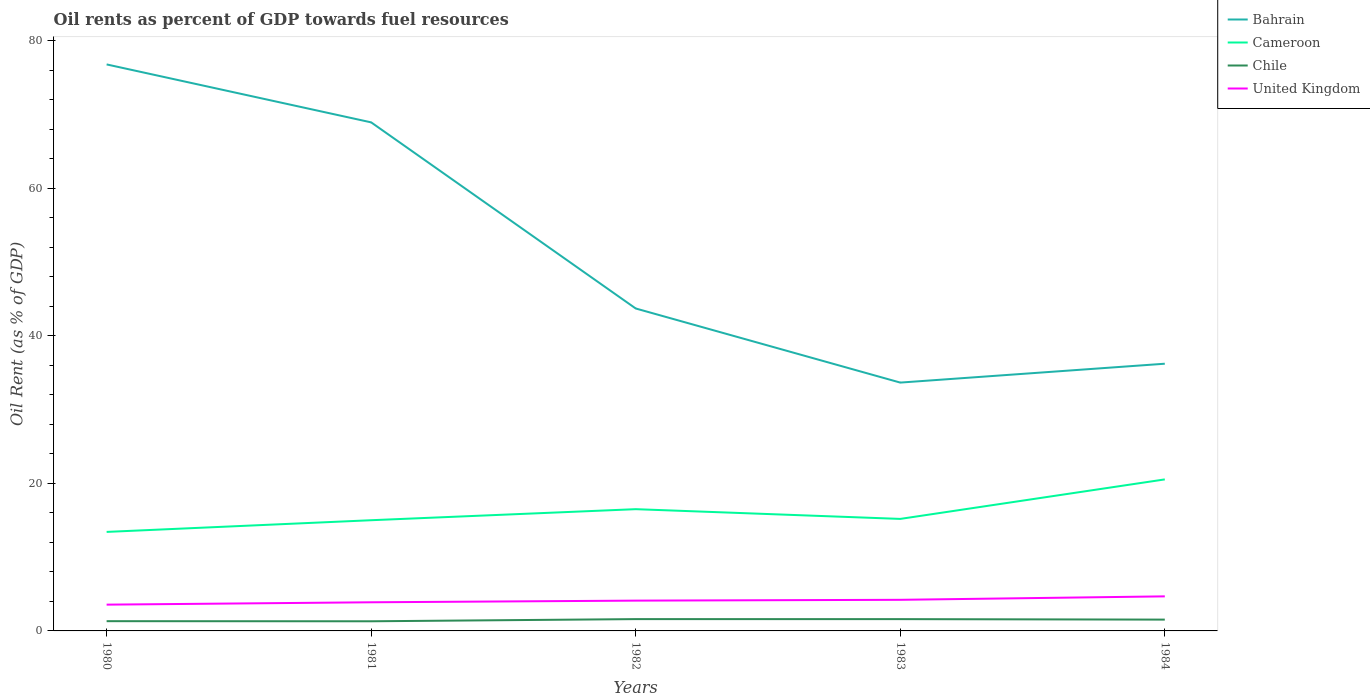Does the line corresponding to Bahrain intersect with the line corresponding to United Kingdom?
Ensure brevity in your answer.  No. Across all years, what is the maximum oil rent in Cameroon?
Make the answer very short. 13.42. In which year was the oil rent in Chile maximum?
Keep it short and to the point. 1981. What is the total oil rent in Cameroon in the graph?
Ensure brevity in your answer.  -3.08. What is the difference between the highest and the second highest oil rent in Cameroon?
Ensure brevity in your answer.  7.12. What is the difference between the highest and the lowest oil rent in United Kingdom?
Keep it short and to the point. 3. How many years are there in the graph?
Provide a short and direct response. 5. What is the difference between two consecutive major ticks on the Y-axis?
Ensure brevity in your answer.  20. Are the values on the major ticks of Y-axis written in scientific E-notation?
Your answer should be compact. No. Does the graph contain any zero values?
Make the answer very short. No. Does the graph contain grids?
Make the answer very short. No. What is the title of the graph?
Offer a terse response. Oil rents as percent of GDP towards fuel resources. What is the label or title of the X-axis?
Provide a short and direct response. Years. What is the label or title of the Y-axis?
Your answer should be compact. Oil Rent (as % of GDP). What is the Oil Rent (as % of GDP) in Bahrain in 1980?
Ensure brevity in your answer.  76.81. What is the Oil Rent (as % of GDP) in Cameroon in 1980?
Ensure brevity in your answer.  13.42. What is the Oil Rent (as % of GDP) in Chile in 1980?
Make the answer very short. 1.32. What is the Oil Rent (as % of GDP) of United Kingdom in 1980?
Provide a short and direct response. 3.56. What is the Oil Rent (as % of GDP) of Bahrain in 1981?
Your answer should be compact. 68.95. What is the Oil Rent (as % of GDP) of Cameroon in 1981?
Give a very brief answer. 15.01. What is the Oil Rent (as % of GDP) of Chile in 1981?
Give a very brief answer. 1.31. What is the Oil Rent (as % of GDP) of United Kingdom in 1981?
Ensure brevity in your answer.  3.88. What is the Oil Rent (as % of GDP) in Bahrain in 1982?
Offer a very short reply. 43.72. What is the Oil Rent (as % of GDP) of Cameroon in 1982?
Your answer should be very brief. 16.51. What is the Oil Rent (as % of GDP) in Chile in 1982?
Offer a terse response. 1.6. What is the Oil Rent (as % of GDP) in United Kingdom in 1982?
Your response must be concise. 4.11. What is the Oil Rent (as % of GDP) in Bahrain in 1983?
Provide a short and direct response. 33.67. What is the Oil Rent (as % of GDP) in Cameroon in 1983?
Provide a short and direct response. 15.19. What is the Oil Rent (as % of GDP) in Chile in 1983?
Ensure brevity in your answer.  1.6. What is the Oil Rent (as % of GDP) in United Kingdom in 1983?
Give a very brief answer. 4.22. What is the Oil Rent (as % of GDP) of Bahrain in 1984?
Your response must be concise. 36.23. What is the Oil Rent (as % of GDP) of Cameroon in 1984?
Provide a short and direct response. 20.54. What is the Oil Rent (as % of GDP) in Chile in 1984?
Give a very brief answer. 1.53. What is the Oil Rent (as % of GDP) in United Kingdom in 1984?
Offer a very short reply. 4.69. Across all years, what is the maximum Oil Rent (as % of GDP) of Bahrain?
Offer a very short reply. 76.81. Across all years, what is the maximum Oil Rent (as % of GDP) in Cameroon?
Ensure brevity in your answer.  20.54. Across all years, what is the maximum Oil Rent (as % of GDP) of Chile?
Offer a very short reply. 1.6. Across all years, what is the maximum Oil Rent (as % of GDP) in United Kingdom?
Give a very brief answer. 4.69. Across all years, what is the minimum Oil Rent (as % of GDP) of Bahrain?
Provide a succinct answer. 33.67. Across all years, what is the minimum Oil Rent (as % of GDP) in Cameroon?
Keep it short and to the point. 13.42. Across all years, what is the minimum Oil Rent (as % of GDP) in Chile?
Offer a terse response. 1.31. Across all years, what is the minimum Oil Rent (as % of GDP) in United Kingdom?
Your response must be concise. 3.56. What is the total Oil Rent (as % of GDP) of Bahrain in the graph?
Provide a succinct answer. 259.38. What is the total Oil Rent (as % of GDP) in Cameroon in the graph?
Your answer should be very brief. 80.67. What is the total Oil Rent (as % of GDP) of Chile in the graph?
Make the answer very short. 7.36. What is the total Oil Rent (as % of GDP) of United Kingdom in the graph?
Your answer should be compact. 20.46. What is the difference between the Oil Rent (as % of GDP) in Bahrain in 1980 and that in 1981?
Your answer should be very brief. 7.86. What is the difference between the Oil Rent (as % of GDP) of Cameroon in 1980 and that in 1981?
Make the answer very short. -1.58. What is the difference between the Oil Rent (as % of GDP) in Chile in 1980 and that in 1981?
Your response must be concise. 0.02. What is the difference between the Oil Rent (as % of GDP) of United Kingdom in 1980 and that in 1981?
Provide a short and direct response. -0.32. What is the difference between the Oil Rent (as % of GDP) in Bahrain in 1980 and that in 1982?
Your answer should be very brief. 33.09. What is the difference between the Oil Rent (as % of GDP) of Cameroon in 1980 and that in 1982?
Your answer should be very brief. -3.08. What is the difference between the Oil Rent (as % of GDP) in Chile in 1980 and that in 1982?
Offer a very short reply. -0.28. What is the difference between the Oil Rent (as % of GDP) in United Kingdom in 1980 and that in 1982?
Give a very brief answer. -0.55. What is the difference between the Oil Rent (as % of GDP) of Bahrain in 1980 and that in 1983?
Your answer should be compact. 43.14. What is the difference between the Oil Rent (as % of GDP) in Cameroon in 1980 and that in 1983?
Your answer should be very brief. -1.76. What is the difference between the Oil Rent (as % of GDP) of Chile in 1980 and that in 1983?
Offer a very short reply. -0.28. What is the difference between the Oil Rent (as % of GDP) in United Kingdom in 1980 and that in 1983?
Make the answer very short. -0.66. What is the difference between the Oil Rent (as % of GDP) in Bahrain in 1980 and that in 1984?
Your answer should be very brief. 40.58. What is the difference between the Oil Rent (as % of GDP) in Cameroon in 1980 and that in 1984?
Offer a very short reply. -7.12. What is the difference between the Oil Rent (as % of GDP) of Chile in 1980 and that in 1984?
Your answer should be very brief. -0.21. What is the difference between the Oil Rent (as % of GDP) in United Kingdom in 1980 and that in 1984?
Provide a short and direct response. -1.12. What is the difference between the Oil Rent (as % of GDP) in Bahrain in 1981 and that in 1982?
Ensure brevity in your answer.  25.23. What is the difference between the Oil Rent (as % of GDP) of Cameroon in 1981 and that in 1982?
Your answer should be very brief. -1.5. What is the difference between the Oil Rent (as % of GDP) in Chile in 1981 and that in 1982?
Provide a succinct answer. -0.29. What is the difference between the Oil Rent (as % of GDP) in United Kingdom in 1981 and that in 1982?
Keep it short and to the point. -0.23. What is the difference between the Oil Rent (as % of GDP) of Bahrain in 1981 and that in 1983?
Provide a succinct answer. 35.28. What is the difference between the Oil Rent (as % of GDP) of Cameroon in 1981 and that in 1983?
Keep it short and to the point. -0.18. What is the difference between the Oil Rent (as % of GDP) of Chile in 1981 and that in 1983?
Give a very brief answer. -0.29. What is the difference between the Oil Rent (as % of GDP) of United Kingdom in 1981 and that in 1983?
Provide a short and direct response. -0.34. What is the difference between the Oil Rent (as % of GDP) of Bahrain in 1981 and that in 1984?
Offer a very short reply. 32.72. What is the difference between the Oil Rent (as % of GDP) in Cameroon in 1981 and that in 1984?
Offer a terse response. -5.54. What is the difference between the Oil Rent (as % of GDP) of Chile in 1981 and that in 1984?
Provide a succinct answer. -0.23. What is the difference between the Oil Rent (as % of GDP) of United Kingdom in 1981 and that in 1984?
Your response must be concise. -0.8. What is the difference between the Oil Rent (as % of GDP) of Bahrain in 1982 and that in 1983?
Ensure brevity in your answer.  10.05. What is the difference between the Oil Rent (as % of GDP) in Cameroon in 1982 and that in 1983?
Offer a very short reply. 1.32. What is the difference between the Oil Rent (as % of GDP) in Chile in 1982 and that in 1983?
Your answer should be compact. 0. What is the difference between the Oil Rent (as % of GDP) of United Kingdom in 1982 and that in 1983?
Give a very brief answer. -0.11. What is the difference between the Oil Rent (as % of GDP) in Bahrain in 1982 and that in 1984?
Make the answer very short. 7.49. What is the difference between the Oil Rent (as % of GDP) of Cameroon in 1982 and that in 1984?
Your answer should be very brief. -4.04. What is the difference between the Oil Rent (as % of GDP) of Chile in 1982 and that in 1984?
Keep it short and to the point. 0.07. What is the difference between the Oil Rent (as % of GDP) in United Kingdom in 1982 and that in 1984?
Keep it short and to the point. -0.58. What is the difference between the Oil Rent (as % of GDP) in Bahrain in 1983 and that in 1984?
Your answer should be compact. -2.56. What is the difference between the Oil Rent (as % of GDP) in Cameroon in 1983 and that in 1984?
Provide a succinct answer. -5.36. What is the difference between the Oil Rent (as % of GDP) of Chile in 1983 and that in 1984?
Your answer should be compact. 0.07. What is the difference between the Oil Rent (as % of GDP) in United Kingdom in 1983 and that in 1984?
Keep it short and to the point. -0.47. What is the difference between the Oil Rent (as % of GDP) in Bahrain in 1980 and the Oil Rent (as % of GDP) in Cameroon in 1981?
Give a very brief answer. 61.8. What is the difference between the Oil Rent (as % of GDP) of Bahrain in 1980 and the Oil Rent (as % of GDP) of Chile in 1981?
Provide a short and direct response. 75.5. What is the difference between the Oil Rent (as % of GDP) of Bahrain in 1980 and the Oil Rent (as % of GDP) of United Kingdom in 1981?
Provide a succinct answer. 72.93. What is the difference between the Oil Rent (as % of GDP) in Cameroon in 1980 and the Oil Rent (as % of GDP) in Chile in 1981?
Provide a short and direct response. 12.12. What is the difference between the Oil Rent (as % of GDP) of Cameroon in 1980 and the Oil Rent (as % of GDP) of United Kingdom in 1981?
Your answer should be very brief. 9.54. What is the difference between the Oil Rent (as % of GDP) in Chile in 1980 and the Oil Rent (as % of GDP) in United Kingdom in 1981?
Your answer should be very brief. -2.56. What is the difference between the Oil Rent (as % of GDP) in Bahrain in 1980 and the Oil Rent (as % of GDP) in Cameroon in 1982?
Provide a short and direct response. 60.3. What is the difference between the Oil Rent (as % of GDP) in Bahrain in 1980 and the Oil Rent (as % of GDP) in Chile in 1982?
Your answer should be very brief. 75.21. What is the difference between the Oil Rent (as % of GDP) of Bahrain in 1980 and the Oil Rent (as % of GDP) of United Kingdom in 1982?
Give a very brief answer. 72.7. What is the difference between the Oil Rent (as % of GDP) of Cameroon in 1980 and the Oil Rent (as % of GDP) of Chile in 1982?
Your answer should be compact. 11.82. What is the difference between the Oil Rent (as % of GDP) in Cameroon in 1980 and the Oil Rent (as % of GDP) in United Kingdom in 1982?
Ensure brevity in your answer.  9.32. What is the difference between the Oil Rent (as % of GDP) in Chile in 1980 and the Oil Rent (as % of GDP) in United Kingdom in 1982?
Ensure brevity in your answer.  -2.79. What is the difference between the Oil Rent (as % of GDP) of Bahrain in 1980 and the Oil Rent (as % of GDP) of Cameroon in 1983?
Give a very brief answer. 61.62. What is the difference between the Oil Rent (as % of GDP) in Bahrain in 1980 and the Oil Rent (as % of GDP) in Chile in 1983?
Offer a very short reply. 75.21. What is the difference between the Oil Rent (as % of GDP) in Bahrain in 1980 and the Oil Rent (as % of GDP) in United Kingdom in 1983?
Give a very brief answer. 72.59. What is the difference between the Oil Rent (as % of GDP) in Cameroon in 1980 and the Oil Rent (as % of GDP) in Chile in 1983?
Give a very brief answer. 11.82. What is the difference between the Oil Rent (as % of GDP) of Cameroon in 1980 and the Oil Rent (as % of GDP) of United Kingdom in 1983?
Provide a succinct answer. 9.21. What is the difference between the Oil Rent (as % of GDP) of Chile in 1980 and the Oil Rent (as % of GDP) of United Kingdom in 1983?
Your response must be concise. -2.9. What is the difference between the Oil Rent (as % of GDP) of Bahrain in 1980 and the Oil Rent (as % of GDP) of Cameroon in 1984?
Your response must be concise. 56.27. What is the difference between the Oil Rent (as % of GDP) in Bahrain in 1980 and the Oil Rent (as % of GDP) in Chile in 1984?
Make the answer very short. 75.28. What is the difference between the Oil Rent (as % of GDP) in Bahrain in 1980 and the Oil Rent (as % of GDP) in United Kingdom in 1984?
Your answer should be very brief. 72.12. What is the difference between the Oil Rent (as % of GDP) of Cameroon in 1980 and the Oil Rent (as % of GDP) of Chile in 1984?
Make the answer very short. 11.89. What is the difference between the Oil Rent (as % of GDP) of Cameroon in 1980 and the Oil Rent (as % of GDP) of United Kingdom in 1984?
Make the answer very short. 8.74. What is the difference between the Oil Rent (as % of GDP) of Chile in 1980 and the Oil Rent (as % of GDP) of United Kingdom in 1984?
Provide a succinct answer. -3.36. What is the difference between the Oil Rent (as % of GDP) of Bahrain in 1981 and the Oil Rent (as % of GDP) of Cameroon in 1982?
Provide a short and direct response. 52.45. What is the difference between the Oil Rent (as % of GDP) in Bahrain in 1981 and the Oil Rent (as % of GDP) in Chile in 1982?
Your answer should be very brief. 67.35. What is the difference between the Oil Rent (as % of GDP) in Bahrain in 1981 and the Oil Rent (as % of GDP) in United Kingdom in 1982?
Provide a succinct answer. 64.84. What is the difference between the Oil Rent (as % of GDP) in Cameroon in 1981 and the Oil Rent (as % of GDP) in Chile in 1982?
Keep it short and to the point. 13.41. What is the difference between the Oil Rent (as % of GDP) in Cameroon in 1981 and the Oil Rent (as % of GDP) in United Kingdom in 1982?
Ensure brevity in your answer.  10.9. What is the difference between the Oil Rent (as % of GDP) in Chile in 1981 and the Oil Rent (as % of GDP) in United Kingdom in 1982?
Offer a terse response. -2.8. What is the difference between the Oil Rent (as % of GDP) in Bahrain in 1981 and the Oil Rent (as % of GDP) in Cameroon in 1983?
Make the answer very short. 53.77. What is the difference between the Oil Rent (as % of GDP) of Bahrain in 1981 and the Oil Rent (as % of GDP) of Chile in 1983?
Offer a very short reply. 67.35. What is the difference between the Oil Rent (as % of GDP) in Bahrain in 1981 and the Oil Rent (as % of GDP) in United Kingdom in 1983?
Your response must be concise. 64.73. What is the difference between the Oil Rent (as % of GDP) of Cameroon in 1981 and the Oil Rent (as % of GDP) of Chile in 1983?
Offer a terse response. 13.41. What is the difference between the Oil Rent (as % of GDP) in Cameroon in 1981 and the Oil Rent (as % of GDP) in United Kingdom in 1983?
Ensure brevity in your answer.  10.79. What is the difference between the Oil Rent (as % of GDP) of Chile in 1981 and the Oil Rent (as % of GDP) of United Kingdom in 1983?
Ensure brevity in your answer.  -2.91. What is the difference between the Oil Rent (as % of GDP) in Bahrain in 1981 and the Oil Rent (as % of GDP) in Cameroon in 1984?
Give a very brief answer. 48.41. What is the difference between the Oil Rent (as % of GDP) of Bahrain in 1981 and the Oil Rent (as % of GDP) of Chile in 1984?
Give a very brief answer. 67.42. What is the difference between the Oil Rent (as % of GDP) of Bahrain in 1981 and the Oil Rent (as % of GDP) of United Kingdom in 1984?
Offer a very short reply. 64.27. What is the difference between the Oil Rent (as % of GDP) in Cameroon in 1981 and the Oil Rent (as % of GDP) in Chile in 1984?
Ensure brevity in your answer.  13.47. What is the difference between the Oil Rent (as % of GDP) in Cameroon in 1981 and the Oil Rent (as % of GDP) in United Kingdom in 1984?
Your answer should be compact. 10.32. What is the difference between the Oil Rent (as % of GDP) of Chile in 1981 and the Oil Rent (as % of GDP) of United Kingdom in 1984?
Offer a very short reply. -3.38. What is the difference between the Oil Rent (as % of GDP) in Bahrain in 1982 and the Oil Rent (as % of GDP) in Cameroon in 1983?
Your answer should be compact. 28.53. What is the difference between the Oil Rent (as % of GDP) in Bahrain in 1982 and the Oil Rent (as % of GDP) in Chile in 1983?
Offer a terse response. 42.12. What is the difference between the Oil Rent (as % of GDP) of Bahrain in 1982 and the Oil Rent (as % of GDP) of United Kingdom in 1983?
Provide a short and direct response. 39.5. What is the difference between the Oil Rent (as % of GDP) in Cameroon in 1982 and the Oil Rent (as % of GDP) in Chile in 1983?
Keep it short and to the point. 14.91. What is the difference between the Oil Rent (as % of GDP) in Cameroon in 1982 and the Oil Rent (as % of GDP) in United Kingdom in 1983?
Your answer should be compact. 12.29. What is the difference between the Oil Rent (as % of GDP) in Chile in 1982 and the Oil Rent (as % of GDP) in United Kingdom in 1983?
Your answer should be compact. -2.62. What is the difference between the Oil Rent (as % of GDP) of Bahrain in 1982 and the Oil Rent (as % of GDP) of Cameroon in 1984?
Offer a terse response. 23.17. What is the difference between the Oil Rent (as % of GDP) in Bahrain in 1982 and the Oil Rent (as % of GDP) in Chile in 1984?
Ensure brevity in your answer.  42.18. What is the difference between the Oil Rent (as % of GDP) in Bahrain in 1982 and the Oil Rent (as % of GDP) in United Kingdom in 1984?
Provide a succinct answer. 39.03. What is the difference between the Oil Rent (as % of GDP) of Cameroon in 1982 and the Oil Rent (as % of GDP) of Chile in 1984?
Give a very brief answer. 14.97. What is the difference between the Oil Rent (as % of GDP) in Cameroon in 1982 and the Oil Rent (as % of GDP) in United Kingdom in 1984?
Your response must be concise. 11.82. What is the difference between the Oil Rent (as % of GDP) in Chile in 1982 and the Oil Rent (as % of GDP) in United Kingdom in 1984?
Provide a short and direct response. -3.09. What is the difference between the Oil Rent (as % of GDP) in Bahrain in 1983 and the Oil Rent (as % of GDP) in Cameroon in 1984?
Your answer should be compact. 13.13. What is the difference between the Oil Rent (as % of GDP) of Bahrain in 1983 and the Oil Rent (as % of GDP) of Chile in 1984?
Provide a succinct answer. 32.14. What is the difference between the Oil Rent (as % of GDP) of Bahrain in 1983 and the Oil Rent (as % of GDP) of United Kingdom in 1984?
Provide a succinct answer. 28.98. What is the difference between the Oil Rent (as % of GDP) of Cameroon in 1983 and the Oil Rent (as % of GDP) of Chile in 1984?
Keep it short and to the point. 13.65. What is the difference between the Oil Rent (as % of GDP) in Cameroon in 1983 and the Oil Rent (as % of GDP) in United Kingdom in 1984?
Your response must be concise. 10.5. What is the difference between the Oil Rent (as % of GDP) in Chile in 1983 and the Oil Rent (as % of GDP) in United Kingdom in 1984?
Give a very brief answer. -3.09. What is the average Oil Rent (as % of GDP) in Bahrain per year?
Offer a very short reply. 51.88. What is the average Oil Rent (as % of GDP) in Cameroon per year?
Offer a very short reply. 16.13. What is the average Oil Rent (as % of GDP) of Chile per year?
Give a very brief answer. 1.47. What is the average Oil Rent (as % of GDP) in United Kingdom per year?
Your answer should be very brief. 4.09. In the year 1980, what is the difference between the Oil Rent (as % of GDP) in Bahrain and Oil Rent (as % of GDP) in Cameroon?
Provide a short and direct response. 63.39. In the year 1980, what is the difference between the Oil Rent (as % of GDP) in Bahrain and Oil Rent (as % of GDP) in Chile?
Your answer should be compact. 75.49. In the year 1980, what is the difference between the Oil Rent (as % of GDP) in Bahrain and Oil Rent (as % of GDP) in United Kingdom?
Make the answer very short. 73.25. In the year 1980, what is the difference between the Oil Rent (as % of GDP) in Cameroon and Oil Rent (as % of GDP) in Chile?
Your response must be concise. 12.1. In the year 1980, what is the difference between the Oil Rent (as % of GDP) in Cameroon and Oil Rent (as % of GDP) in United Kingdom?
Ensure brevity in your answer.  9.86. In the year 1980, what is the difference between the Oil Rent (as % of GDP) of Chile and Oil Rent (as % of GDP) of United Kingdom?
Give a very brief answer. -2.24. In the year 1981, what is the difference between the Oil Rent (as % of GDP) of Bahrain and Oil Rent (as % of GDP) of Cameroon?
Your answer should be very brief. 53.94. In the year 1981, what is the difference between the Oil Rent (as % of GDP) of Bahrain and Oil Rent (as % of GDP) of Chile?
Your response must be concise. 67.65. In the year 1981, what is the difference between the Oil Rent (as % of GDP) of Bahrain and Oil Rent (as % of GDP) of United Kingdom?
Keep it short and to the point. 65.07. In the year 1981, what is the difference between the Oil Rent (as % of GDP) of Cameroon and Oil Rent (as % of GDP) of Chile?
Offer a very short reply. 13.7. In the year 1981, what is the difference between the Oil Rent (as % of GDP) in Cameroon and Oil Rent (as % of GDP) in United Kingdom?
Provide a succinct answer. 11.13. In the year 1981, what is the difference between the Oil Rent (as % of GDP) in Chile and Oil Rent (as % of GDP) in United Kingdom?
Offer a very short reply. -2.58. In the year 1982, what is the difference between the Oil Rent (as % of GDP) of Bahrain and Oil Rent (as % of GDP) of Cameroon?
Make the answer very short. 27.21. In the year 1982, what is the difference between the Oil Rent (as % of GDP) of Bahrain and Oil Rent (as % of GDP) of Chile?
Your answer should be compact. 42.12. In the year 1982, what is the difference between the Oil Rent (as % of GDP) of Bahrain and Oil Rent (as % of GDP) of United Kingdom?
Offer a terse response. 39.61. In the year 1982, what is the difference between the Oil Rent (as % of GDP) in Cameroon and Oil Rent (as % of GDP) in Chile?
Your answer should be very brief. 14.91. In the year 1982, what is the difference between the Oil Rent (as % of GDP) in Cameroon and Oil Rent (as % of GDP) in United Kingdom?
Provide a short and direct response. 12.4. In the year 1982, what is the difference between the Oil Rent (as % of GDP) of Chile and Oil Rent (as % of GDP) of United Kingdom?
Your response must be concise. -2.51. In the year 1983, what is the difference between the Oil Rent (as % of GDP) in Bahrain and Oil Rent (as % of GDP) in Cameroon?
Give a very brief answer. 18.48. In the year 1983, what is the difference between the Oil Rent (as % of GDP) in Bahrain and Oil Rent (as % of GDP) in Chile?
Provide a succinct answer. 32.07. In the year 1983, what is the difference between the Oil Rent (as % of GDP) of Bahrain and Oil Rent (as % of GDP) of United Kingdom?
Give a very brief answer. 29.45. In the year 1983, what is the difference between the Oil Rent (as % of GDP) of Cameroon and Oil Rent (as % of GDP) of Chile?
Ensure brevity in your answer.  13.59. In the year 1983, what is the difference between the Oil Rent (as % of GDP) of Cameroon and Oil Rent (as % of GDP) of United Kingdom?
Ensure brevity in your answer.  10.97. In the year 1983, what is the difference between the Oil Rent (as % of GDP) in Chile and Oil Rent (as % of GDP) in United Kingdom?
Make the answer very short. -2.62. In the year 1984, what is the difference between the Oil Rent (as % of GDP) in Bahrain and Oil Rent (as % of GDP) in Cameroon?
Offer a very short reply. 15.68. In the year 1984, what is the difference between the Oil Rent (as % of GDP) in Bahrain and Oil Rent (as % of GDP) in Chile?
Keep it short and to the point. 34.69. In the year 1984, what is the difference between the Oil Rent (as % of GDP) of Bahrain and Oil Rent (as % of GDP) of United Kingdom?
Give a very brief answer. 31.54. In the year 1984, what is the difference between the Oil Rent (as % of GDP) in Cameroon and Oil Rent (as % of GDP) in Chile?
Give a very brief answer. 19.01. In the year 1984, what is the difference between the Oil Rent (as % of GDP) of Cameroon and Oil Rent (as % of GDP) of United Kingdom?
Make the answer very short. 15.86. In the year 1984, what is the difference between the Oil Rent (as % of GDP) of Chile and Oil Rent (as % of GDP) of United Kingdom?
Your answer should be very brief. -3.15. What is the ratio of the Oil Rent (as % of GDP) of Bahrain in 1980 to that in 1981?
Ensure brevity in your answer.  1.11. What is the ratio of the Oil Rent (as % of GDP) of Cameroon in 1980 to that in 1981?
Offer a very short reply. 0.89. What is the ratio of the Oil Rent (as % of GDP) in Chile in 1980 to that in 1981?
Keep it short and to the point. 1.01. What is the ratio of the Oil Rent (as % of GDP) of United Kingdom in 1980 to that in 1981?
Offer a very short reply. 0.92. What is the ratio of the Oil Rent (as % of GDP) in Bahrain in 1980 to that in 1982?
Ensure brevity in your answer.  1.76. What is the ratio of the Oil Rent (as % of GDP) of Cameroon in 1980 to that in 1982?
Make the answer very short. 0.81. What is the ratio of the Oil Rent (as % of GDP) in Chile in 1980 to that in 1982?
Your response must be concise. 0.83. What is the ratio of the Oil Rent (as % of GDP) of United Kingdom in 1980 to that in 1982?
Provide a short and direct response. 0.87. What is the ratio of the Oil Rent (as % of GDP) of Bahrain in 1980 to that in 1983?
Keep it short and to the point. 2.28. What is the ratio of the Oil Rent (as % of GDP) of Cameroon in 1980 to that in 1983?
Your answer should be compact. 0.88. What is the ratio of the Oil Rent (as % of GDP) of Chile in 1980 to that in 1983?
Ensure brevity in your answer.  0.83. What is the ratio of the Oil Rent (as % of GDP) of United Kingdom in 1980 to that in 1983?
Offer a terse response. 0.84. What is the ratio of the Oil Rent (as % of GDP) of Bahrain in 1980 to that in 1984?
Provide a succinct answer. 2.12. What is the ratio of the Oil Rent (as % of GDP) of Cameroon in 1980 to that in 1984?
Offer a very short reply. 0.65. What is the ratio of the Oil Rent (as % of GDP) of Chile in 1980 to that in 1984?
Offer a terse response. 0.86. What is the ratio of the Oil Rent (as % of GDP) of United Kingdom in 1980 to that in 1984?
Provide a succinct answer. 0.76. What is the ratio of the Oil Rent (as % of GDP) of Bahrain in 1981 to that in 1982?
Offer a terse response. 1.58. What is the ratio of the Oil Rent (as % of GDP) in Cameroon in 1981 to that in 1982?
Provide a succinct answer. 0.91. What is the ratio of the Oil Rent (as % of GDP) of Chile in 1981 to that in 1982?
Offer a terse response. 0.82. What is the ratio of the Oil Rent (as % of GDP) in United Kingdom in 1981 to that in 1982?
Your answer should be compact. 0.95. What is the ratio of the Oil Rent (as % of GDP) of Bahrain in 1981 to that in 1983?
Ensure brevity in your answer.  2.05. What is the ratio of the Oil Rent (as % of GDP) of Cameroon in 1981 to that in 1983?
Make the answer very short. 0.99. What is the ratio of the Oil Rent (as % of GDP) in Chile in 1981 to that in 1983?
Your answer should be very brief. 0.82. What is the ratio of the Oil Rent (as % of GDP) of United Kingdom in 1981 to that in 1983?
Keep it short and to the point. 0.92. What is the ratio of the Oil Rent (as % of GDP) in Bahrain in 1981 to that in 1984?
Give a very brief answer. 1.9. What is the ratio of the Oil Rent (as % of GDP) in Cameroon in 1981 to that in 1984?
Your answer should be very brief. 0.73. What is the ratio of the Oil Rent (as % of GDP) of Chile in 1981 to that in 1984?
Your answer should be compact. 0.85. What is the ratio of the Oil Rent (as % of GDP) in United Kingdom in 1981 to that in 1984?
Your response must be concise. 0.83. What is the ratio of the Oil Rent (as % of GDP) of Bahrain in 1982 to that in 1983?
Give a very brief answer. 1.3. What is the ratio of the Oil Rent (as % of GDP) in Cameroon in 1982 to that in 1983?
Keep it short and to the point. 1.09. What is the ratio of the Oil Rent (as % of GDP) of Chile in 1982 to that in 1983?
Your answer should be very brief. 1. What is the ratio of the Oil Rent (as % of GDP) in Bahrain in 1982 to that in 1984?
Your answer should be very brief. 1.21. What is the ratio of the Oil Rent (as % of GDP) in Cameroon in 1982 to that in 1984?
Give a very brief answer. 0.8. What is the ratio of the Oil Rent (as % of GDP) in Chile in 1982 to that in 1984?
Your answer should be compact. 1.04. What is the ratio of the Oil Rent (as % of GDP) of United Kingdom in 1982 to that in 1984?
Offer a very short reply. 0.88. What is the ratio of the Oil Rent (as % of GDP) of Bahrain in 1983 to that in 1984?
Offer a terse response. 0.93. What is the ratio of the Oil Rent (as % of GDP) in Cameroon in 1983 to that in 1984?
Provide a succinct answer. 0.74. What is the ratio of the Oil Rent (as % of GDP) of Chile in 1983 to that in 1984?
Give a very brief answer. 1.04. What is the ratio of the Oil Rent (as % of GDP) in United Kingdom in 1983 to that in 1984?
Your response must be concise. 0.9. What is the difference between the highest and the second highest Oil Rent (as % of GDP) in Bahrain?
Give a very brief answer. 7.86. What is the difference between the highest and the second highest Oil Rent (as % of GDP) of Cameroon?
Offer a terse response. 4.04. What is the difference between the highest and the second highest Oil Rent (as % of GDP) of Chile?
Your response must be concise. 0. What is the difference between the highest and the second highest Oil Rent (as % of GDP) of United Kingdom?
Keep it short and to the point. 0.47. What is the difference between the highest and the lowest Oil Rent (as % of GDP) of Bahrain?
Your answer should be very brief. 43.14. What is the difference between the highest and the lowest Oil Rent (as % of GDP) of Cameroon?
Make the answer very short. 7.12. What is the difference between the highest and the lowest Oil Rent (as % of GDP) of Chile?
Your answer should be very brief. 0.29. What is the difference between the highest and the lowest Oil Rent (as % of GDP) in United Kingdom?
Ensure brevity in your answer.  1.12. 